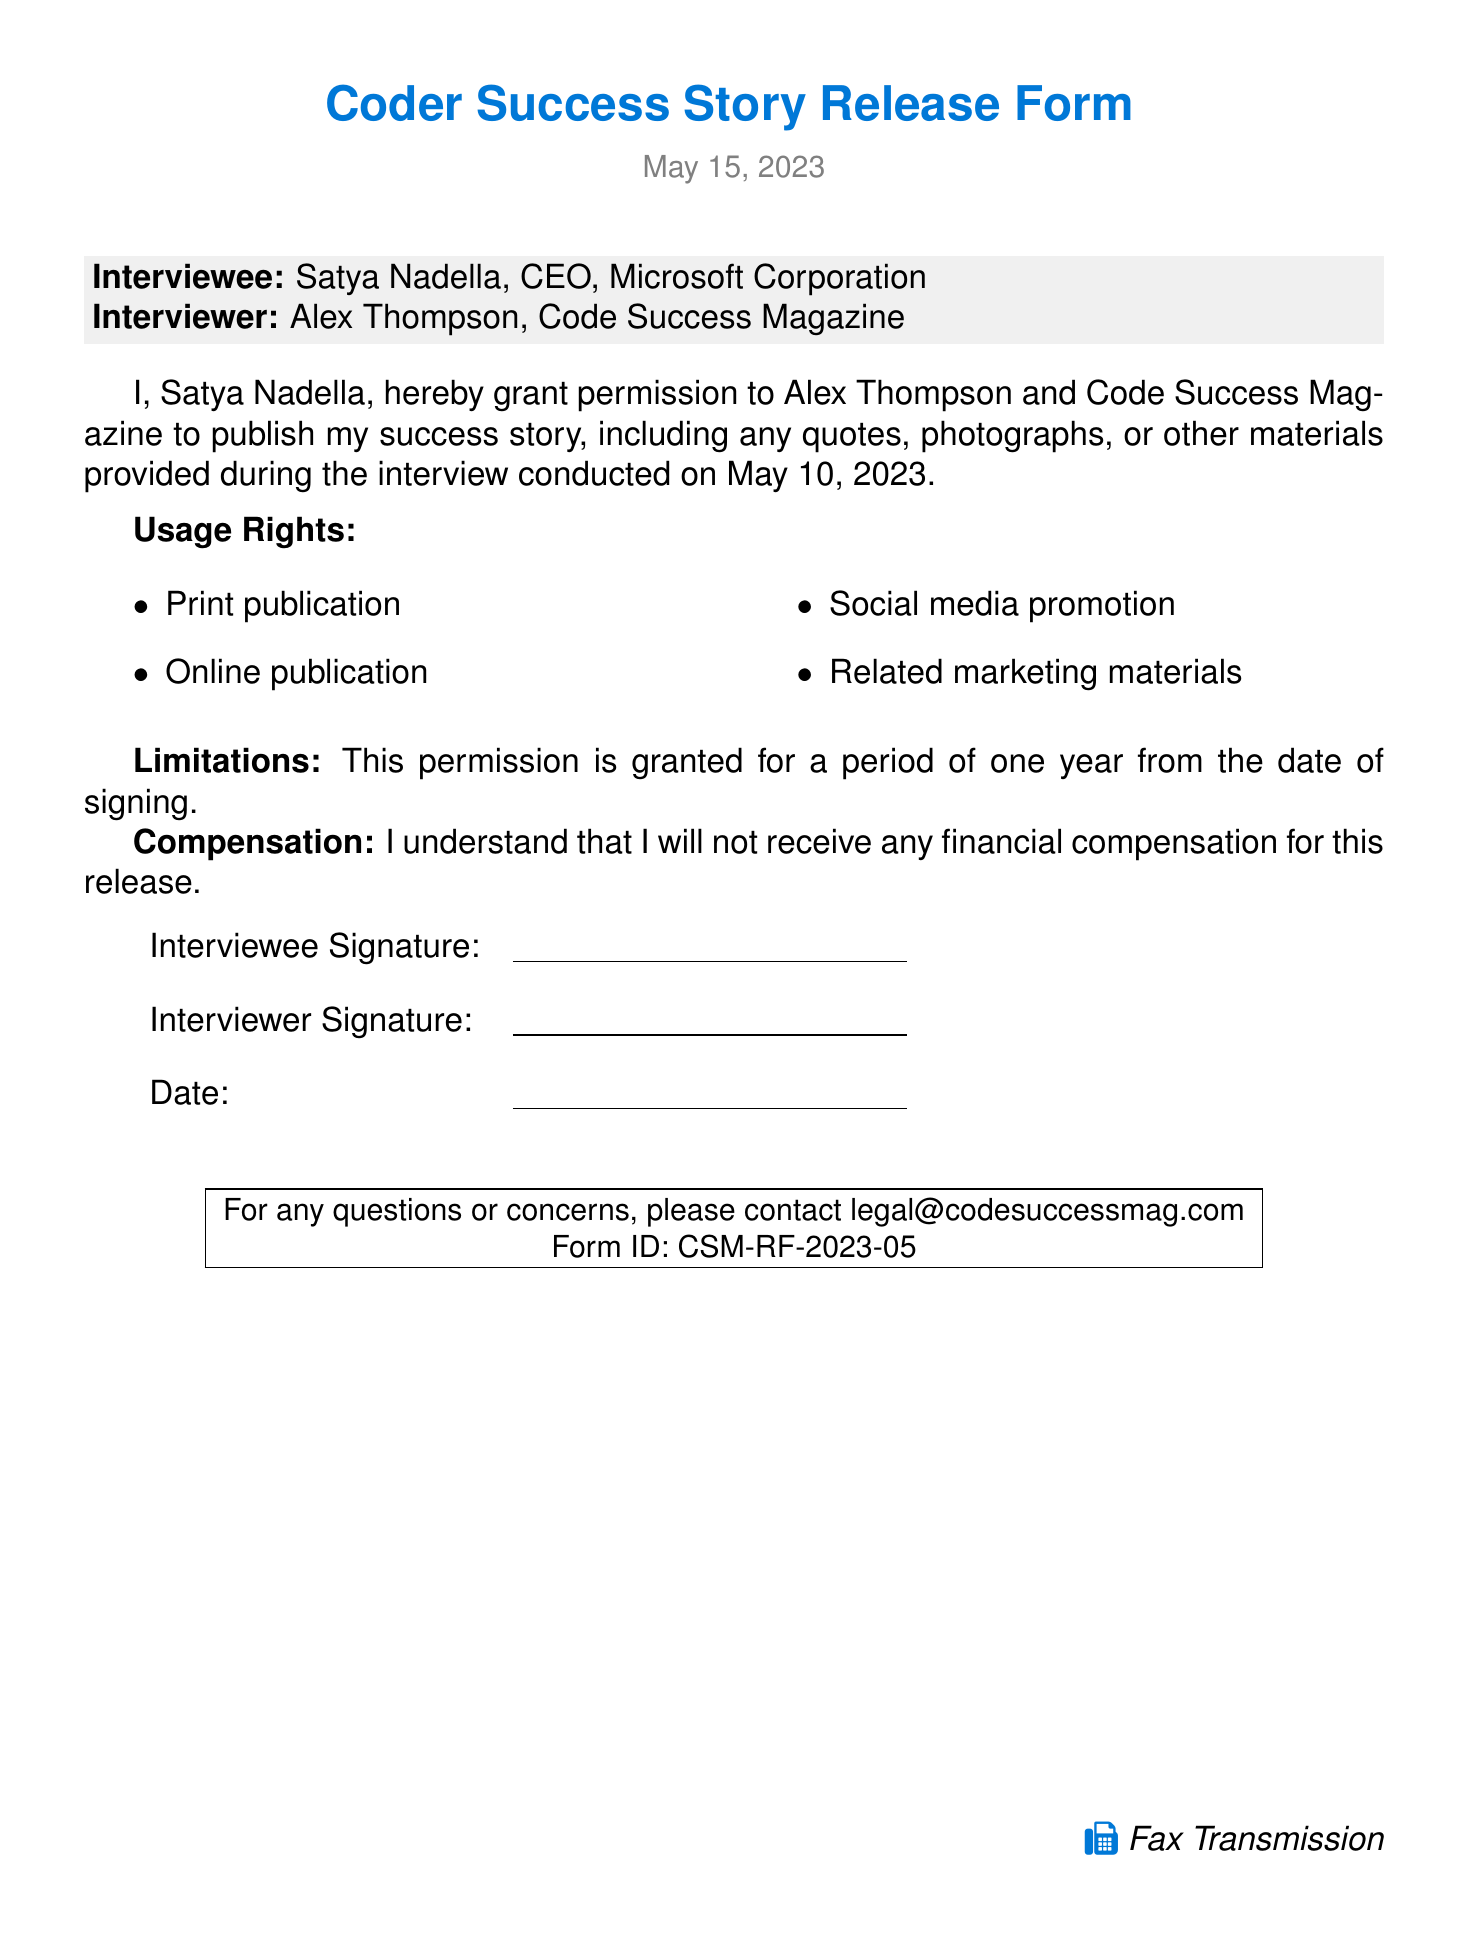What is the name of the interviewee? The interviewee is identified as Satya Nadella in the document.
Answer: Satya Nadella What is the title of the interviewee? The title of Satya Nadella mentioned in the document is CEO of Microsoft Corporation.
Answer: CEO Who is the interviewer? The document states that the interviewer is Alex Thompson.
Answer: Alex Thompson What is the date of the interview? The document specifies that the interview took place on May 10, 2023.
Answer: May 10, 2023 What is the release date of the document? The document notes the release date as May 15, 2023.
Answer: May 15, 2023 What organization is mentioned as the publisher? The document identifies Code Success Magazine as the publisher.
Answer: Code Success Magazine What type of publications does the release form permit? The document lists print publication, online publication, social media promotion, and related marketing materials.
Answer: Print, online, social media, marketing How long is the permission granted for? The document states that permission is granted for a period of one year.
Answer: One year Will the interviewee receive financial compensation? The document makes it clear that there will be no financial compensation provided.
Answer: No 